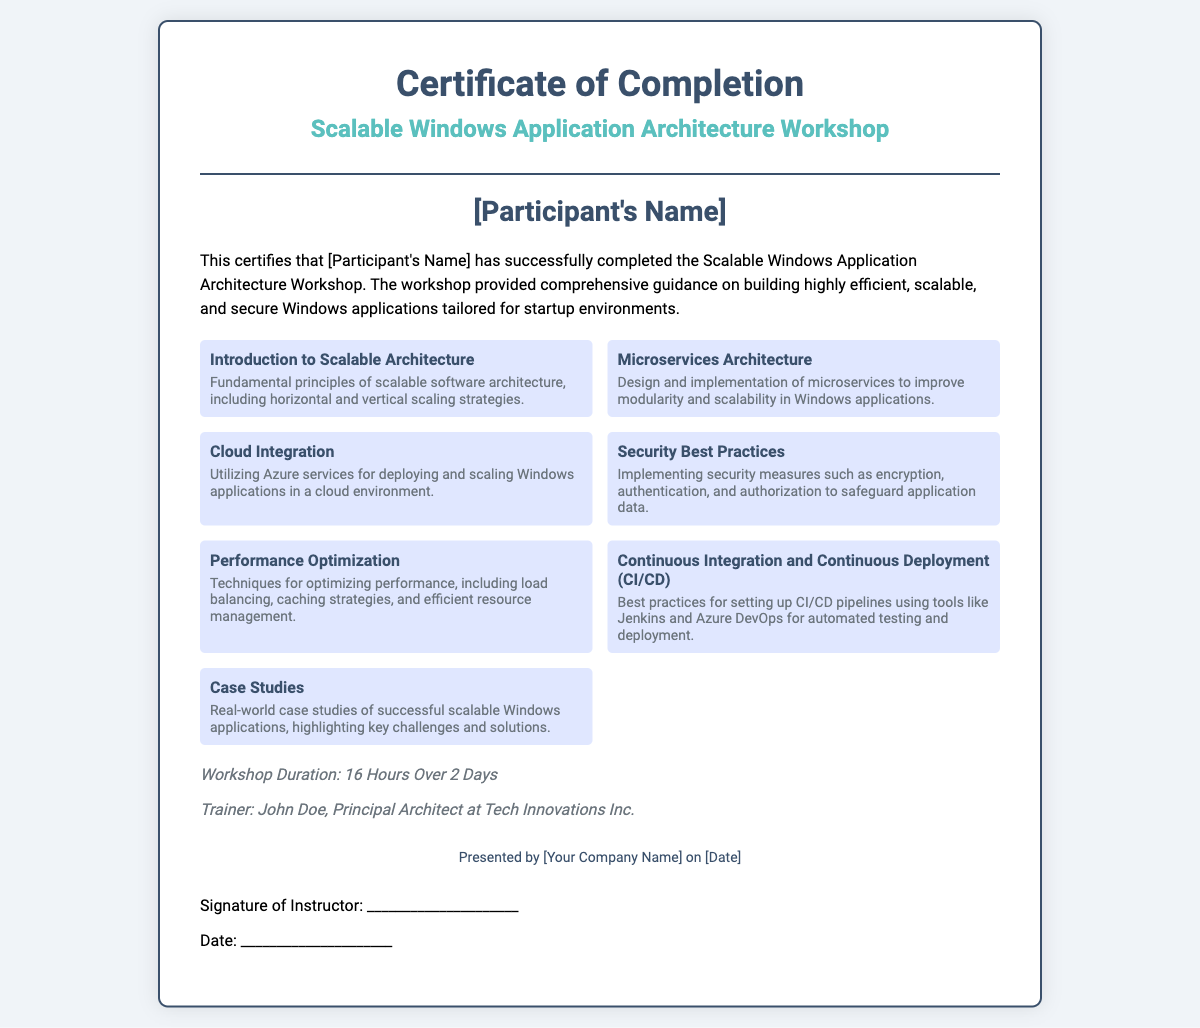what is the title of the workshop? The title of the workshop is prominently displayed in the certificate under the main heading.
Answer: Scalable Windows Application Architecture Workshop who is the instructor of the workshop? The instructor's name is mentioned in the credits section of the document.
Answer: John Doe what is the total duration of the workshop? The duration of the workshop is specified in the credits section.
Answer: 16 Hours Over 2 Days what is one topic covered related to security? One of the topics listed in the body discusses security measures specifically.
Answer: Security Best Practices what type of architecture is discussed for improving modularity? The document mentions a specific architectural approach aimed at enhancing modularity.
Answer: Microservices Architecture how many distinct topics are covered in the workshop? The number of topics presented can be counted from the topics section of the document.
Answer: 7 what is the main goal of the workshop? The overall purpose of the workshop is outlined in the introduction paragraph.
Answer: Building highly efficient, scalable, and secure Windows applications 